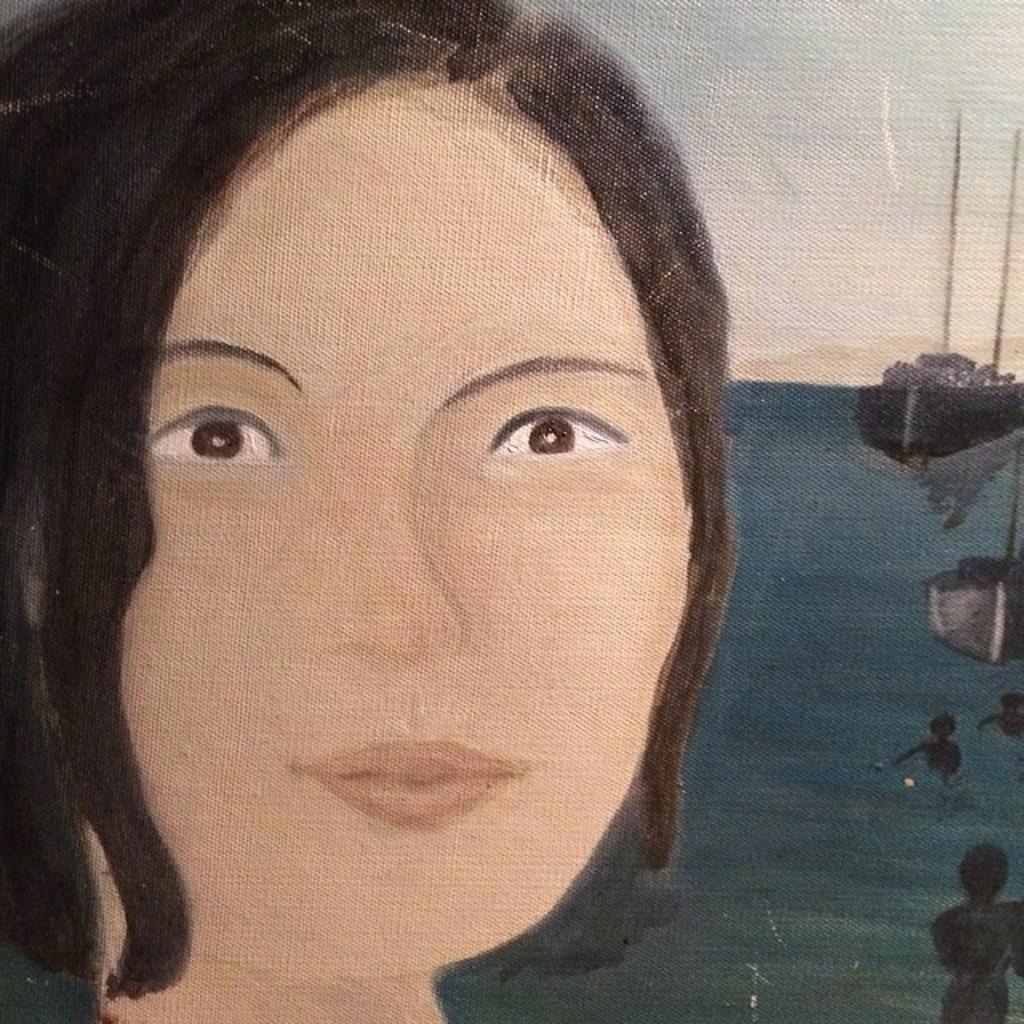What is the main subject of the painting in the image? The main subject of the painting in the image is a lady. What other elements are included in the painting? The painting depicts water, a boat, and the sky. What type of tin can be seen in the painting? There is no tin present in the painting; it features a lady, water, a boat, and the sky. 